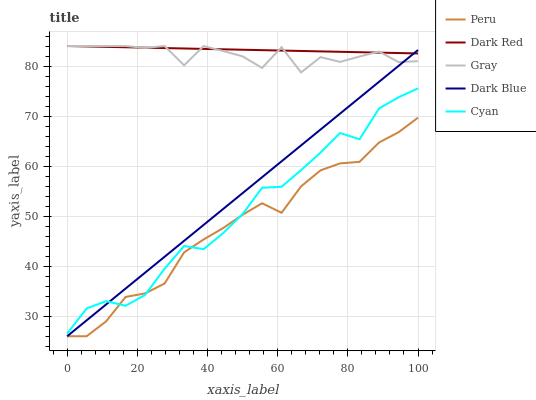Does Cyan have the minimum area under the curve?
Answer yes or no. No. Does Cyan have the maximum area under the curve?
Answer yes or no. No. Is Cyan the smoothest?
Answer yes or no. No. Is Cyan the roughest?
Answer yes or no. No. Does Cyan have the lowest value?
Answer yes or no. No. Does Cyan have the highest value?
Answer yes or no. No. Is Cyan less than Dark Red?
Answer yes or no. Yes. Is Dark Red greater than Cyan?
Answer yes or no. Yes. Does Cyan intersect Dark Red?
Answer yes or no. No. 